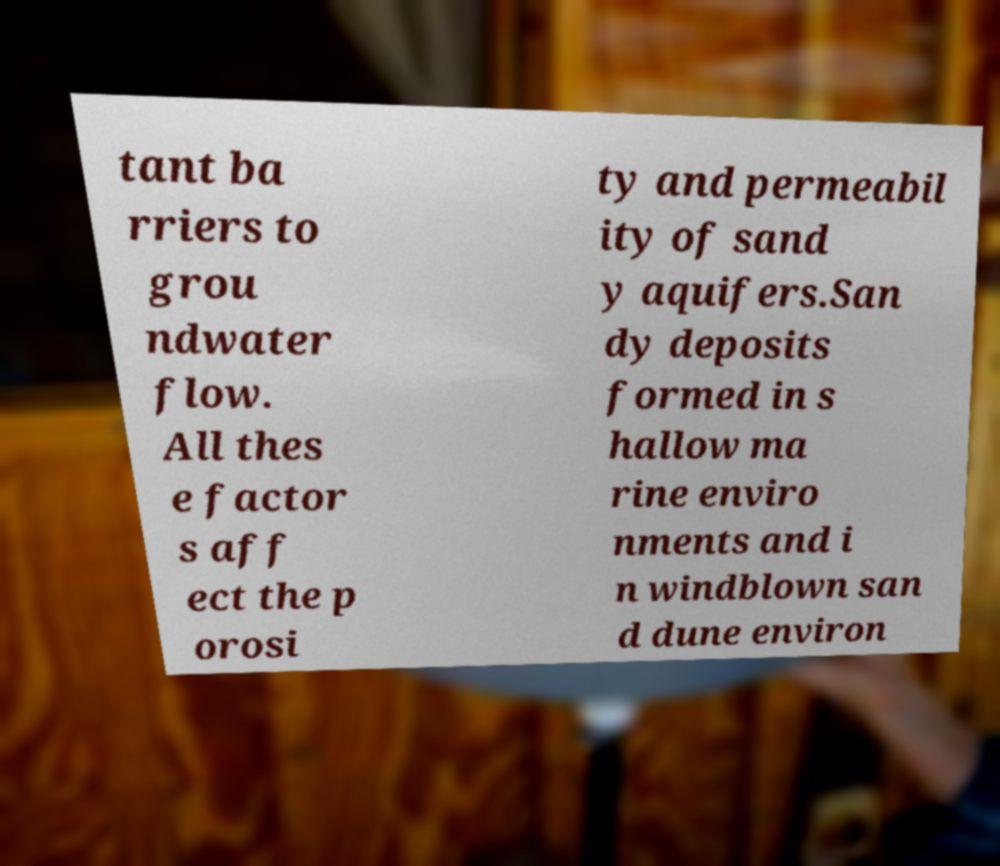Could you assist in decoding the text presented in this image and type it out clearly? tant ba rriers to grou ndwater flow. All thes e factor s aff ect the p orosi ty and permeabil ity of sand y aquifers.San dy deposits formed in s hallow ma rine enviro nments and i n windblown san d dune environ 